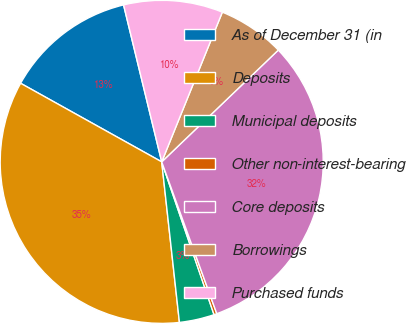<chart> <loc_0><loc_0><loc_500><loc_500><pie_chart><fcel>As of December 31 (in<fcel>Deposits<fcel>Municipal deposits<fcel>Other non-interest-bearing<fcel>Core deposits<fcel>Borrowings<fcel>Purchased funds<nl><fcel>13.12%<fcel>34.84%<fcel>3.5%<fcel>0.29%<fcel>31.63%<fcel>6.71%<fcel>9.92%<nl></chart> 